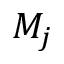Convert formula to latex. <formula><loc_0><loc_0><loc_500><loc_500>M _ { j }</formula> 